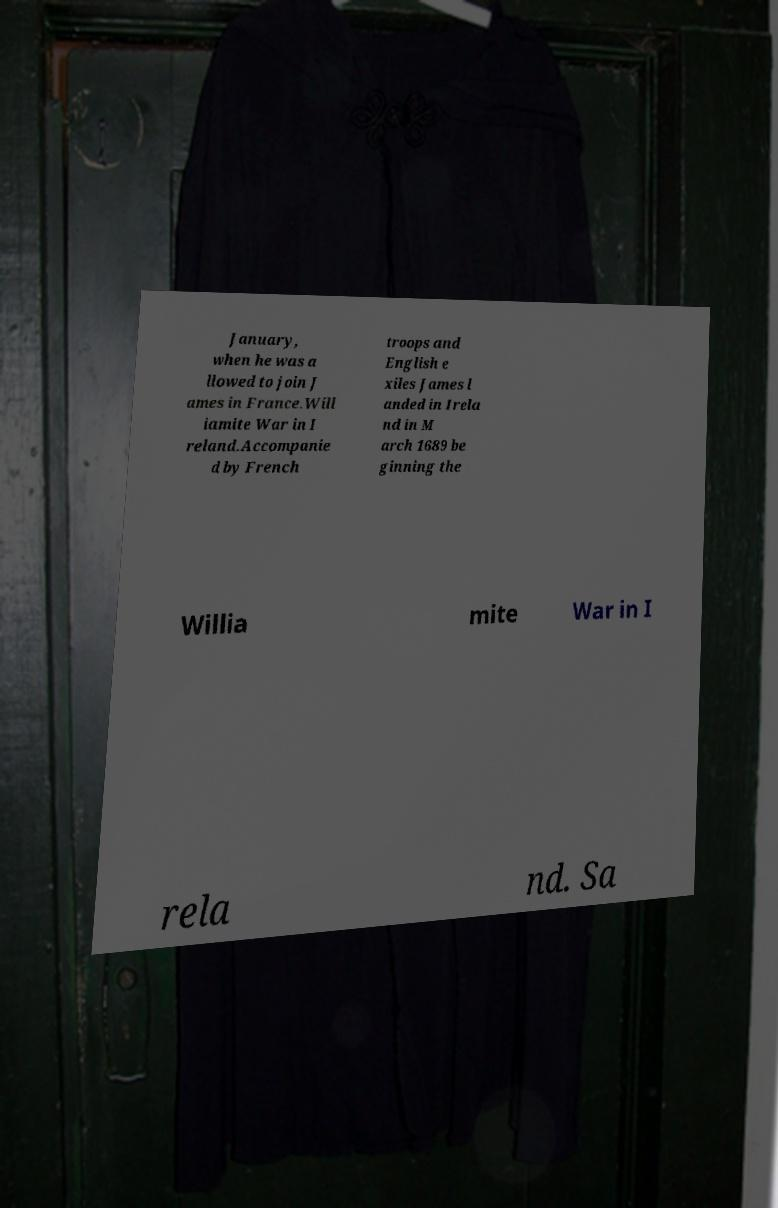There's text embedded in this image that I need extracted. Can you transcribe it verbatim? January, when he was a llowed to join J ames in France.Will iamite War in I reland.Accompanie d by French troops and English e xiles James l anded in Irela nd in M arch 1689 be ginning the Willia mite War in I rela nd. Sa 